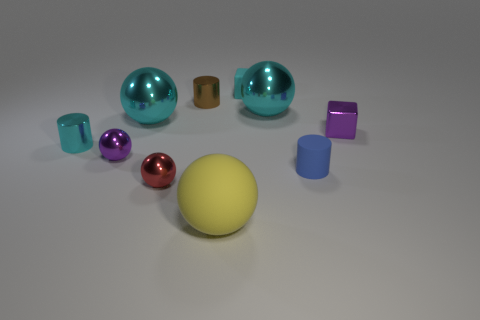Subtract all small brown cylinders. How many cylinders are left? 2 Subtract all cyan cubes. How many cyan balls are left? 2 Subtract all blocks. How many objects are left? 8 Subtract 1 cylinders. How many cylinders are left? 2 Subtract all blue cylinders. How many cylinders are left? 2 Subtract 0 blue cubes. How many objects are left? 10 Subtract all yellow spheres. Subtract all blue cylinders. How many spheres are left? 4 Subtract all big gray rubber cylinders. Subtract all tiny rubber objects. How many objects are left? 8 Add 7 purple metallic blocks. How many purple metallic blocks are left? 8 Add 9 small green cylinders. How many small green cylinders exist? 9 